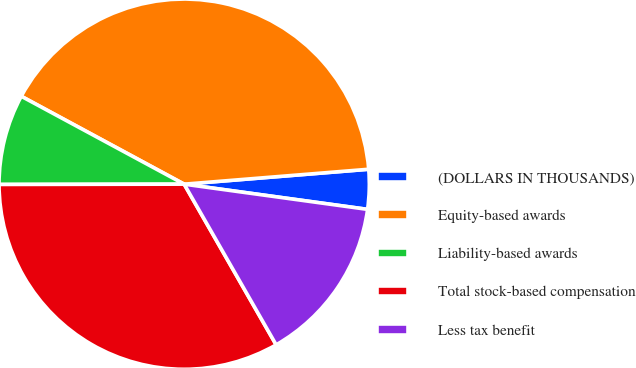Convert chart. <chart><loc_0><loc_0><loc_500><loc_500><pie_chart><fcel>(DOLLARS IN THOUSANDS)<fcel>Equity-based awards<fcel>Liability-based awards<fcel>Total stock-based compensation<fcel>Less tax benefit<nl><fcel>3.46%<fcel>40.84%<fcel>7.9%<fcel>33.25%<fcel>14.55%<nl></chart> 